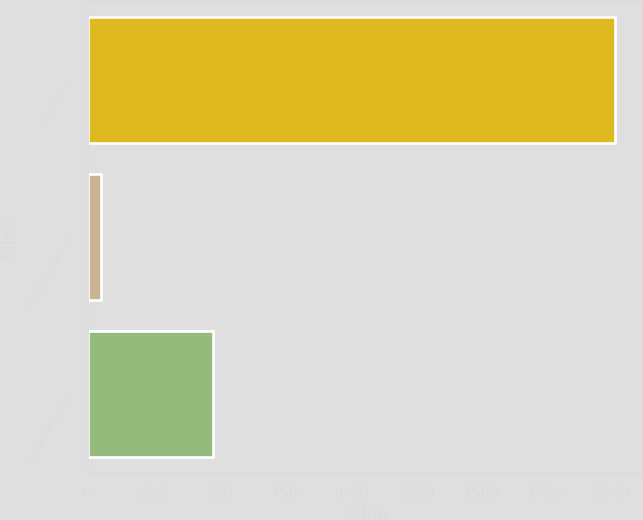Convert chart. <chart><loc_0><loc_0><loc_500><loc_500><bar_chart><fcel>December 31<fcel>General accounts (a)<fcel>Limited partnership<nl><fcel>2015<fcel>49<fcel>478<nl></chart> 